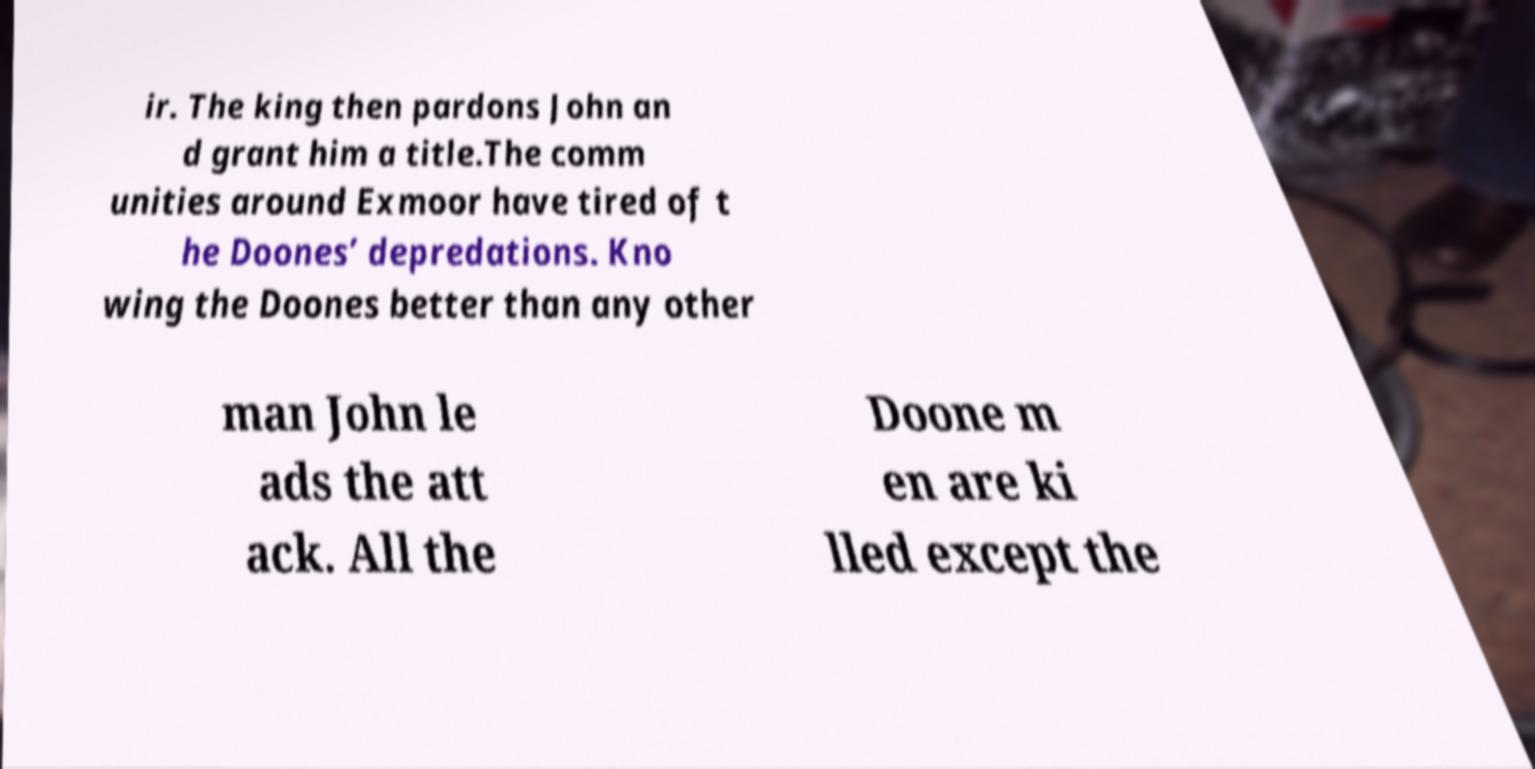Can you read and provide the text displayed in the image?This photo seems to have some interesting text. Can you extract and type it out for me? ir. The king then pardons John an d grant him a title.The comm unities around Exmoor have tired of t he Doones’ depredations. Kno wing the Doones better than any other man John le ads the att ack. All the Doone m en are ki lled except the 